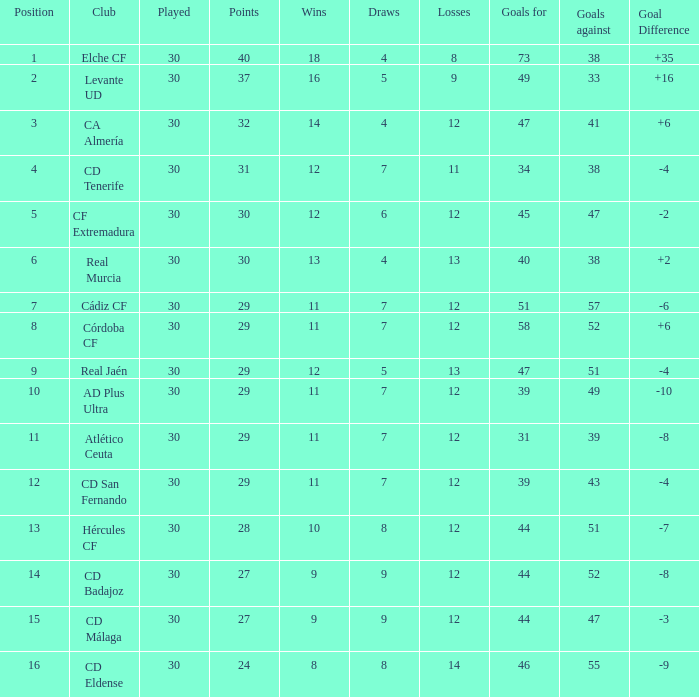What is the number of goals with less than 14 wins and a goal difference less than -4? 51, 39, 31, 44, 44, 46. 